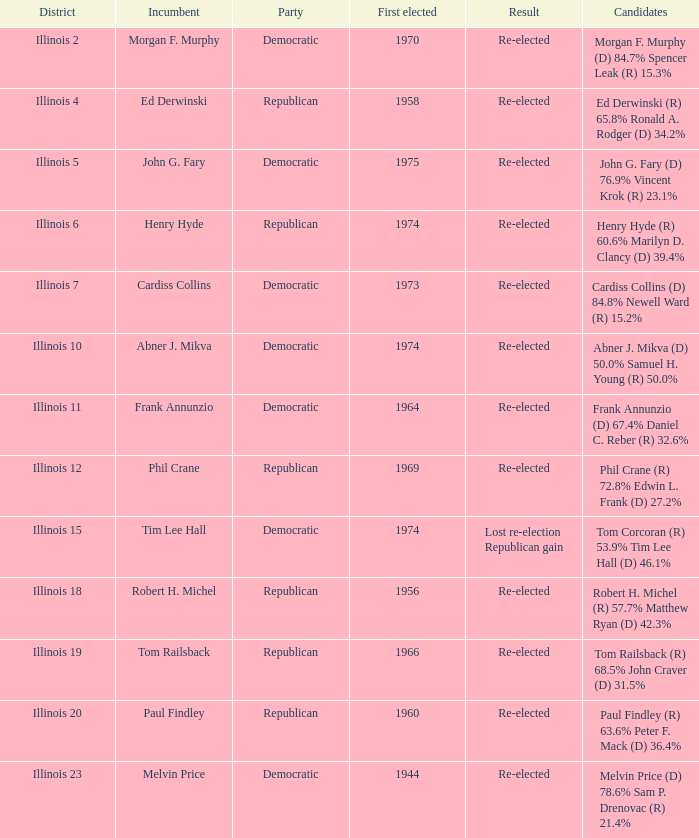Identify the party taking place in tim lee hall. Democratic. 